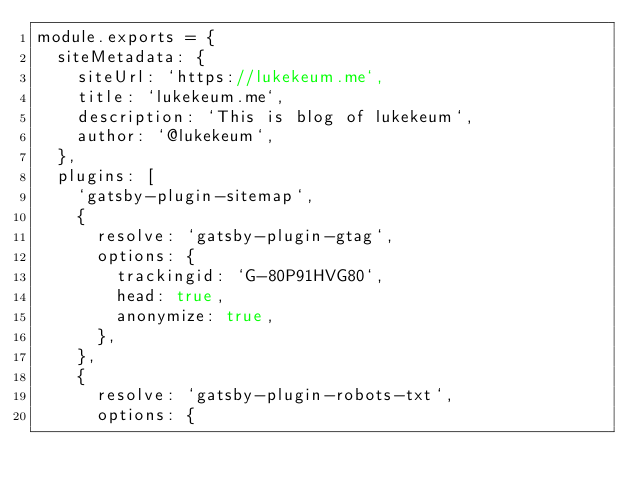Convert code to text. <code><loc_0><loc_0><loc_500><loc_500><_JavaScript_>module.exports = {
  siteMetadata: {
    siteUrl: `https://lukekeum.me`,
    title: `lukekeum.me`,
    description: `This is blog of lukekeum`,
    author: `@lukekeum`,
  },
  plugins: [
    `gatsby-plugin-sitemap`,
    {
      resolve: `gatsby-plugin-gtag`,
      options: {
        trackingid: `G-80P91HVG80`,
        head: true,
        anonymize: true,
      },
    },
    {
      resolve: `gatsby-plugin-robots-txt`,
      options: {</code> 